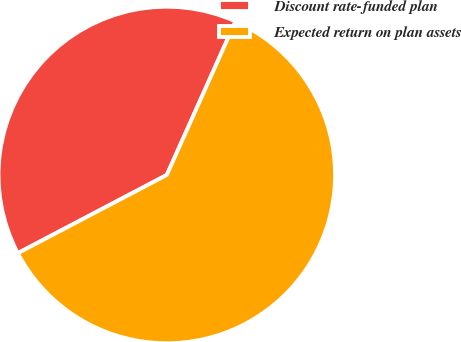<chart> <loc_0><loc_0><loc_500><loc_500><pie_chart><fcel>Discount rate-funded plan<fcel>Expected return on plan assets<nl><fcel>39.39%<fcel>60.61%<nl></chart> 